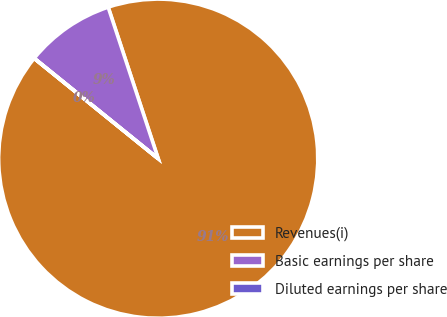Convert chart to OTSL. <chart><loc_0><loc_0><loc_500><loc_500><pie_chart><fcel>Revenues(i)<fcel>Basic earnings per share<fcel>Diluted earnings per share<nl><fcel>90.9%<fcel>9.09%<fcel>0.01%<nl></chart> 